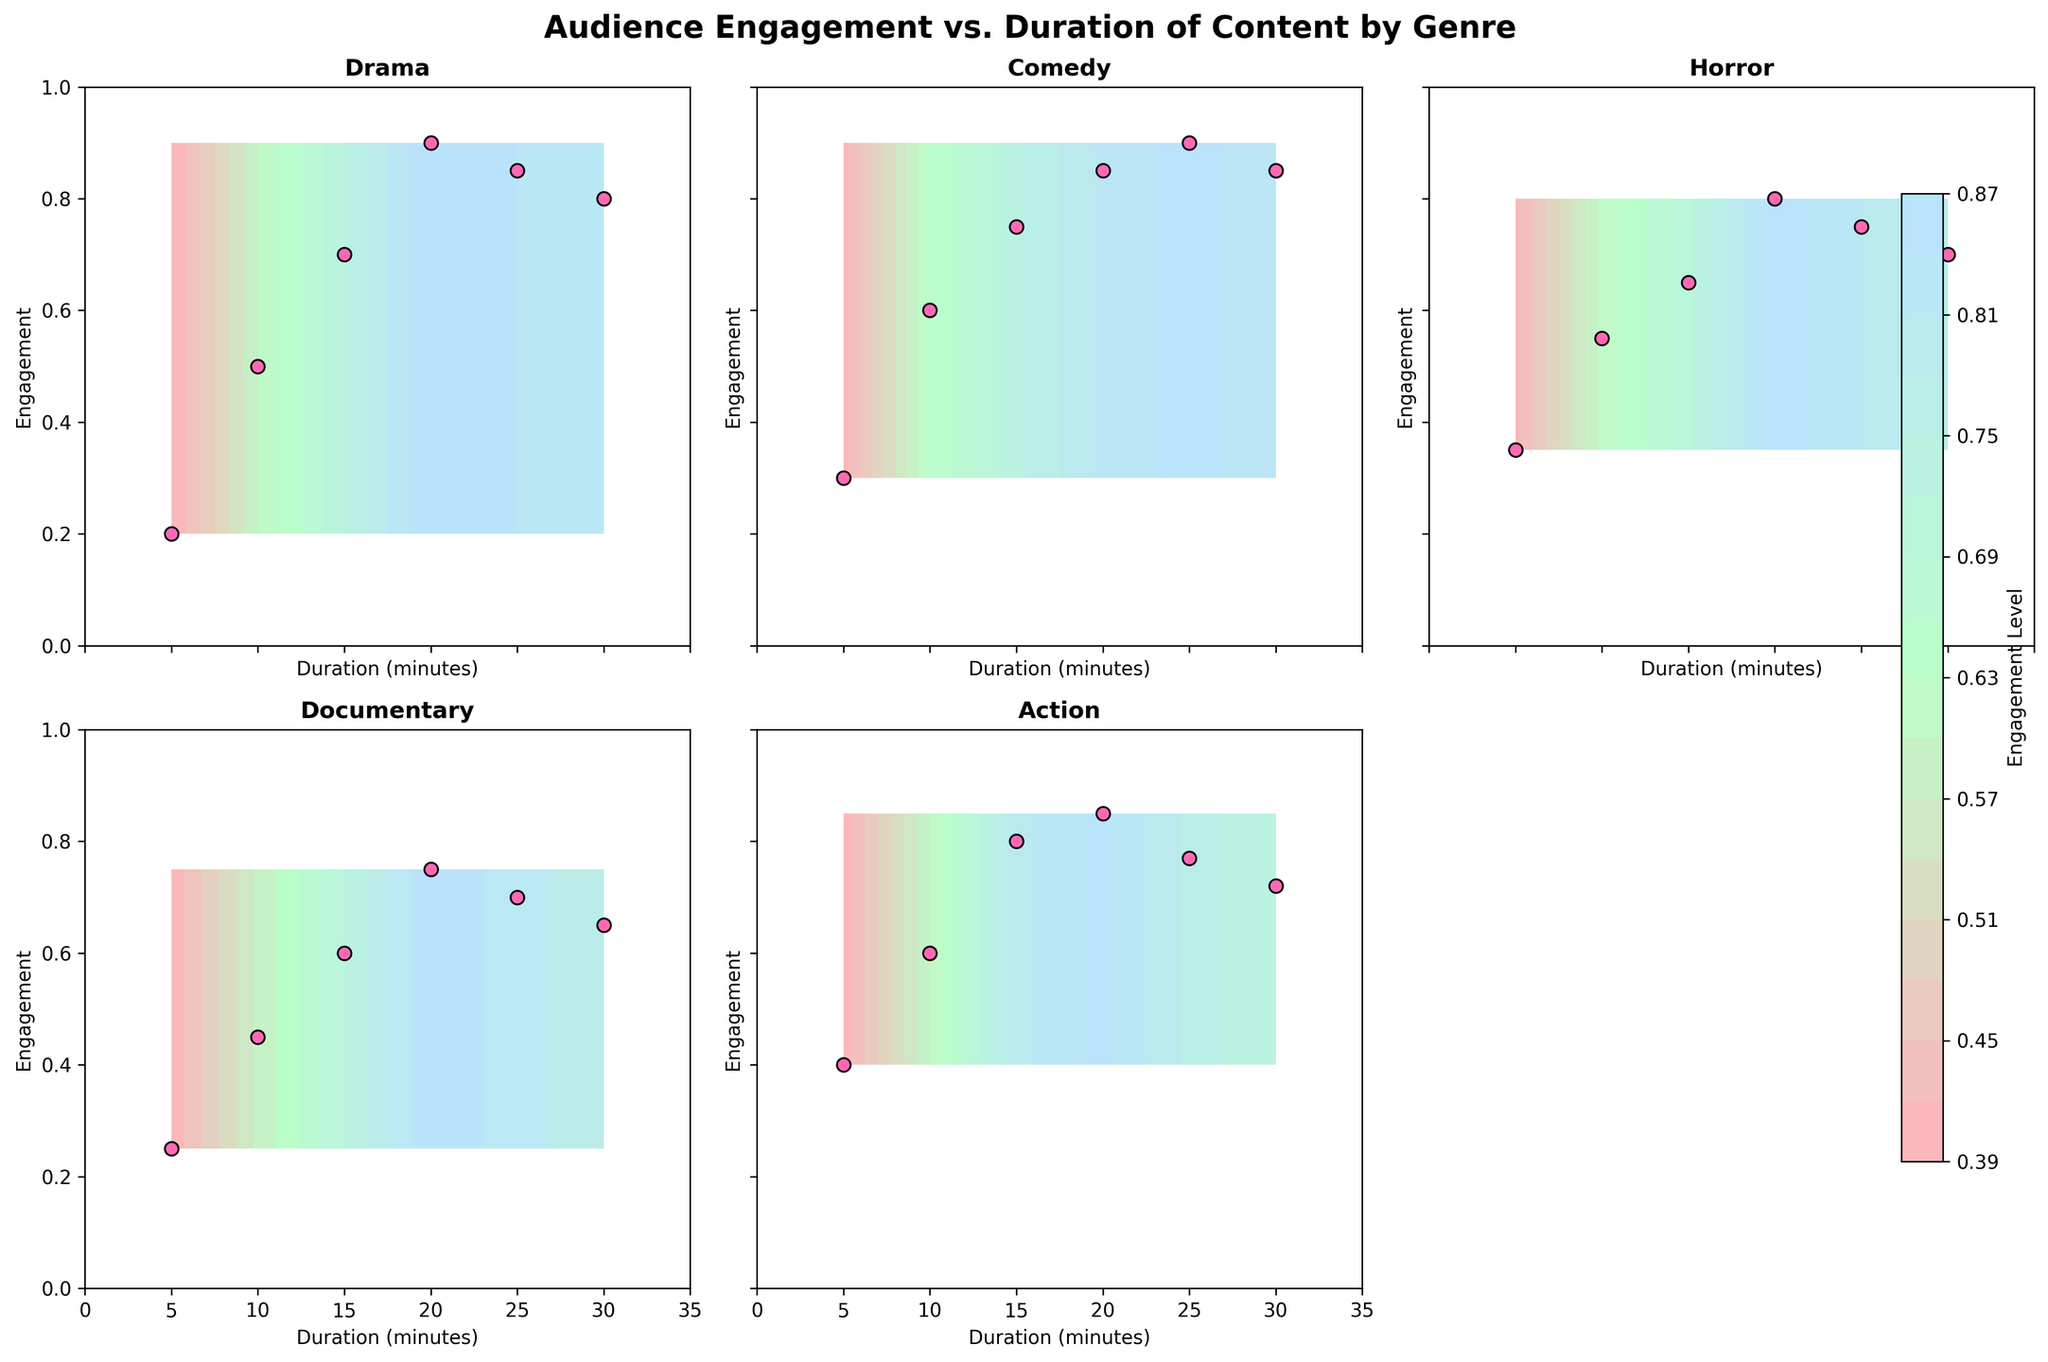What is the title of the figure? The title of the figure is usually located at the top and is designed to inform the viewer about the main theme or data being presented. In this case, the title is "Audience Engagement vs. Duration of Content by Genre".
Answer: Audience Engagement vs. Duration of Content by Genre How many subplots are in the figure? The figure is divided into smaller sections called subplots. We see there are multiple subplots in a grid arrangement, each representing a different genre. By counting them, we see there are 5 subplots: Drama, Comedy, Horror, Documentary, and Action.
Answer: 5 What genre shows the highest peak in engagement? To determine the highest engagement, locate the peak point in each subplot. Action has the highest peak close to 0.85 around 20 minutes of duration.
Answer: Action Which genre has an empty subplot space in the figure? By inspecting the subplots, we observe that one subplot area is devoid of any data, located in the bottom right corner. This represents an empty subplot space.
Answer: None Which genre shows a declining trend in engagement as duration increases from 25 to 30 minutes? To find the trend, look at the points plotted on each subplot from 25 to 30 minutes. For Drama, the engagement decreases from 0.85 to 0.8, indicating a declining trend.
Answer: Drama Which genre has the most scatter points clustered in the higher engagement range? Higher engagement can be seen towards the top of the subplot (closer to 1). Comedy has most of its scatter points clustered around higher engagement values, especially between 0.75 and 0.9.
Answer: Comedy Compare the engagement levels for Horror and Documentary at the 20-minute mark. Which is higher? By matching the duration of 20 minutes on the Horror and Documentary subplots, we can compare their engagement values. Horror has an engagement level of 0.8, while Documentary’s engagement is 0.75, making Horror higher.
Answer: Horror What is the engagement difference between Drama and Comedy at the 15-minute mark? Look at the engagement values for both Drama and Comedy at 15 minutes. Drama is at 0.7, and Comedy is at 0.75. The difference can be calculated as 0.75 - 0.7 = 0.05.
Answer: 0.05 What color is used for the scatter points representing the data? By inspecting the scatter points in each subplot, it's evident they are all colored in pink.
Answer: Pink Is there a color gradient used in the contours? If so, describe it. The contours in each subplot use a color gradient that transitions from light to dark. This suggests a custom colormap that blends different shades of colors to represent various levels of engagement.
Answer: Yes, a gradient from light to dark 